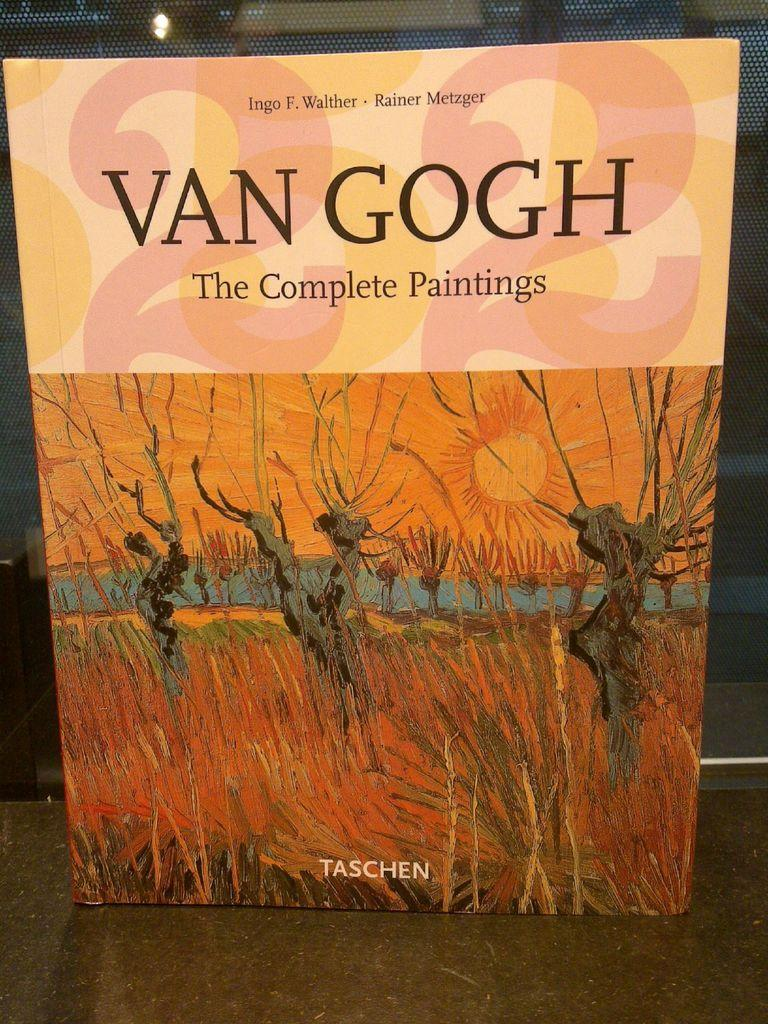<image>
Render a clear and concise summary of the photo. A book of Van Gogh's complete painting is standing up on a table. 